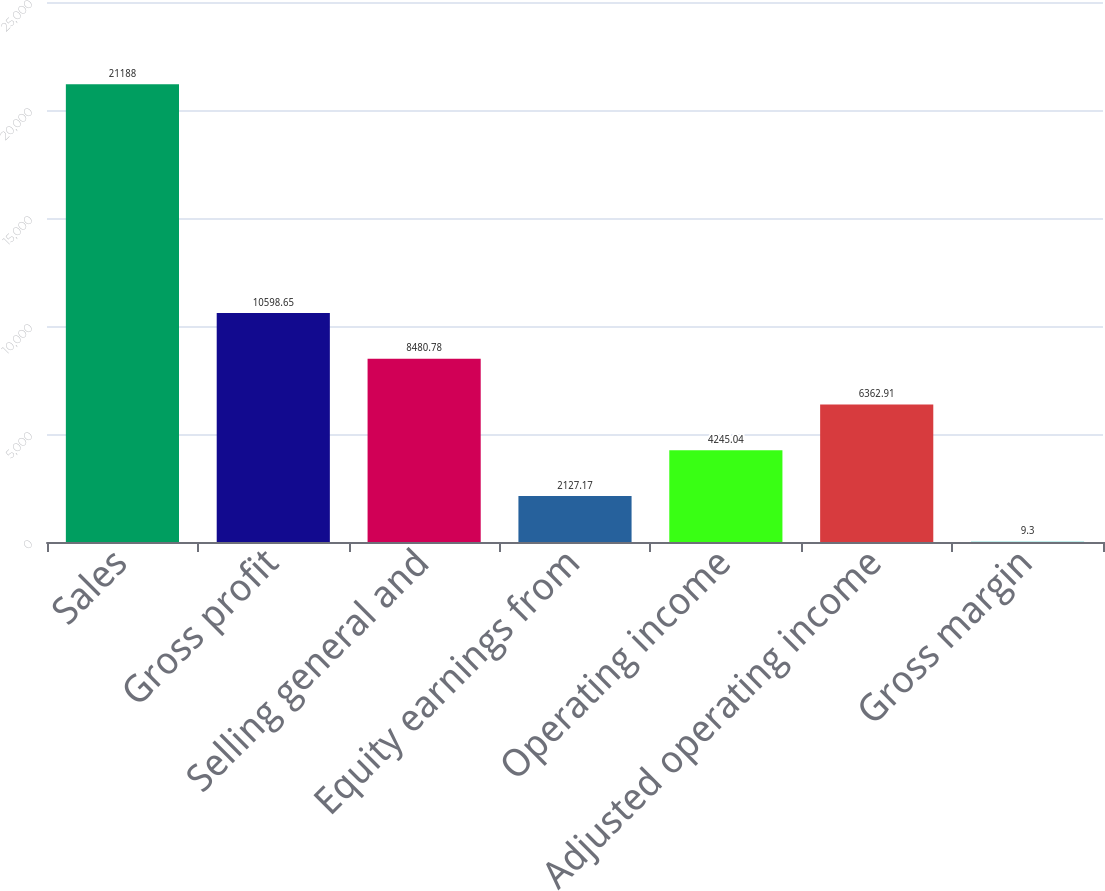Convert chart to OTSL. <chart><loc_0><loc_0><loc_500><loc_500><bar_chart><fcel>Sales<fcel>Gross profit<fcel>Selling general and<fcel>Equity earnings from<fcel>Operating income<fcel>Adjusted operating income<fcel>Gross margin<nl><fcel>21188<fcel>10598.6<fcel>8480.78<fcel>2127.17<fcel>4245.04<fcel>6362.91<fcel>9.3<nl></chart> 